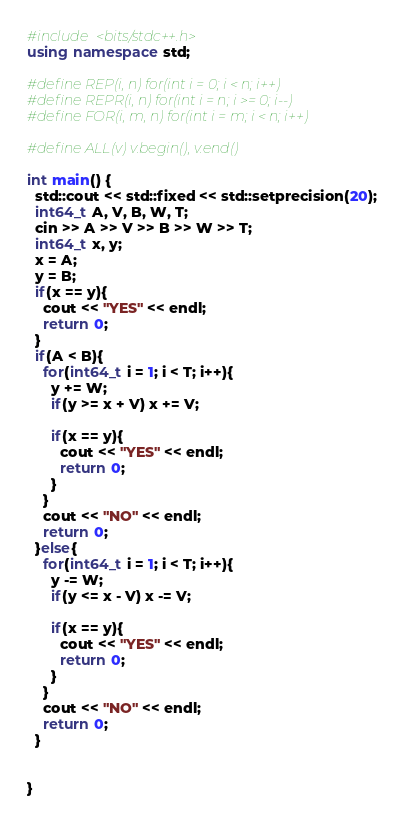<code> <loc_0><loc_0><loc_500><loc_500><_C++_>#include <bits/stdc++.h>
using namespace std;

#define REP(i, n) for(int i = 0; i < n; i++)
#define REPR(i, n) for(int i = n; i >= 0; i--)
#define FOR(i, m, n) for(int i = m; i < n; i++)

#define ALL(v) v.begin(), v.end()

int main() {
  std::cout << std::fixed << std::setprecision(20);
  int64_t A, V, B, W, T;
  cin >> A >> V >> B >> W >> T;
  int64_t x, y;
  x = A;
  y = B;
  if(x == y){
    cout << "YES" << endl;
    return 0;
  }
  if(A < B){
    for(int64_t i = 1; i < T; i++){    
      y += W;
      if(y >= x + V) x += V;

      if(x == y){
        cout << "YES" << endl;
        return 0;
      }
    }
    cout << "NO" << endl;
    return 0;
  }else{
    for(int64_t i = 1; i < T; i++){    
      y -= W;
      if(y <= x - V) x -= V;

      if(x == y){
        cout << "YES" << endl;
        return 0;
      }
    }
    cout << "NO" << endl;
    return 0;
  }
  

}</code> 